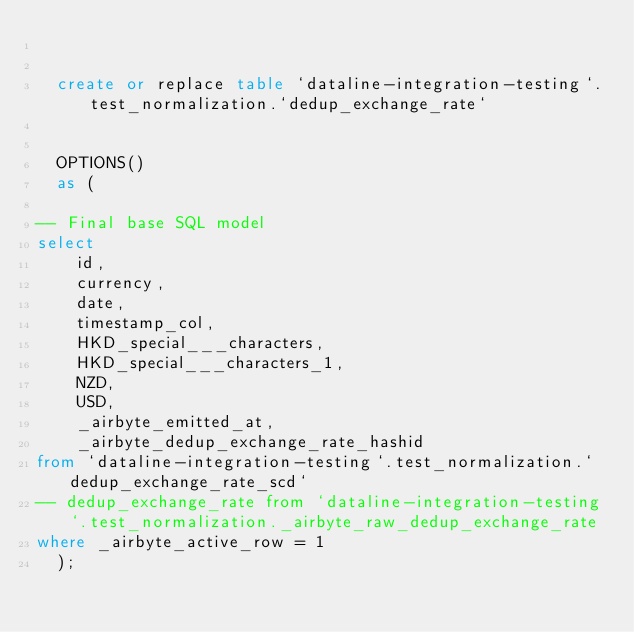<code> <loc_0><loc_0><loc_500><loc_500><_SQL_>

  create or replace table `dataline-integration-testing`.test_normalization.`dedup_exchange_rate`
  
  
  OPTIONS()
  as (
    
-- Final base SQL model
select
    id,
    currency,
    date,
    timestamp_col,
    HKD_special___characters,
    HKD_special___characters_1,
    NZD,
    USD,
    _airbyte_emitted_at,
    _airbyte_dedup_exchange_rate_hashid
from `dataline-integration-testing`.test_normalization.`dedup_exchange_rate_scd`
-- dedup_exchange_rate from `dataline-integration-testing`.test_normalization._airbyte_raw_dedup_exchange_rate
where _airbyte_active_row = 1
  );
    </code> 